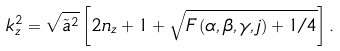<formula> <loc_0><loc_0><loc_500><loc_500>k _ { z } ^ { 2 } = \sqrt { \tilde { a } ^ { 2 } } \left [ 2 n _ { z } + 1 + \sqrt { F \left ( \alpha , \beta , \gamma , j \right ) + 1 / 4 } \right ] .</formula> 